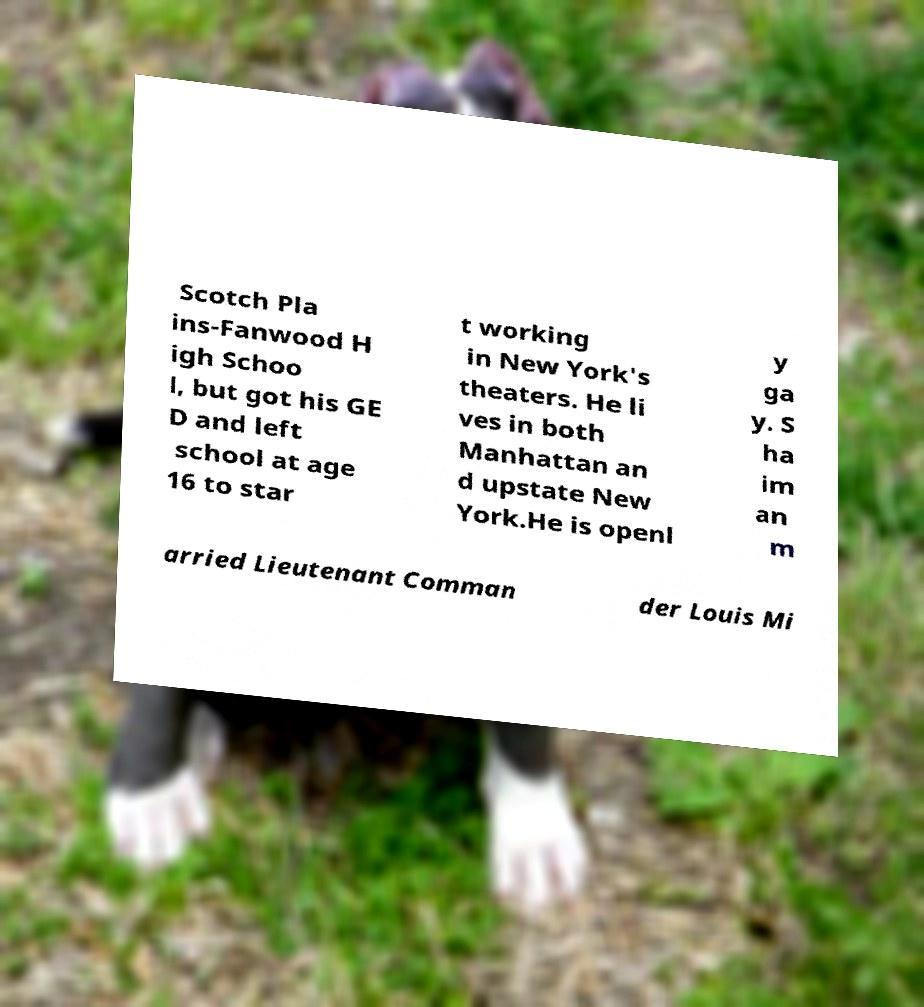Could you assist in decoding the text presented in this image and type it out clearly? Scotch Pla ins-Fanwood H igh Schoo l, but got his GE D and left school at age 16 to star t working in New York's theaters. He li ves in both Manhattan an d upstate New York.He is openl y ga y. S ha im an m arried Lieutenant Comman der Louis Mi 